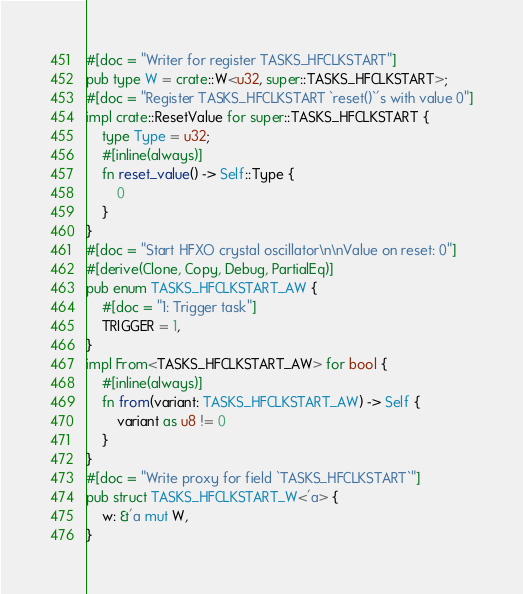Convert code to text. <code><loc_0><loc_0><loc_500><loc_500><_Rust_>#[doc = "Writer for register TASKS_HFCLKSTART"]
pub type W = crate::W<u32, super::TASKS_HFCLKSTART>;
#[doc = "Register TASKS_HFCLKSTART `reset()`'s with value 0"]
impl crate::ResetValue for super::TASKS_HFCLKSTART {
    type Type = u32;
    #[inline(always)]
    fn reset_value() -> Self::Type {
        0
    }
}
#[doc = "Start HFXO crystal oscillator\n\nValue on reset: 0"]
#[derive(Clone, Copy, Debug, PartialEq)]
pub enum TASKS_HFCLKSTART_AW {
    #[doc = "1: Trigger task"]
    TRIGGER = 1,
}
impl From<TASKS_HFCLKSTART_AW> for bool {
    #[inline(always)]
    fn from(variant: TASKS_HFCLKSTART_AW) -> Self {
        variant as u8 != 0
    }
}
#[doc = "Write proxy for field `TASKS_HFCLKSTART`"]
pub struct TASKS_HFCLKSTART_W<'a> {
    w: &'a mut W,
}</code> 